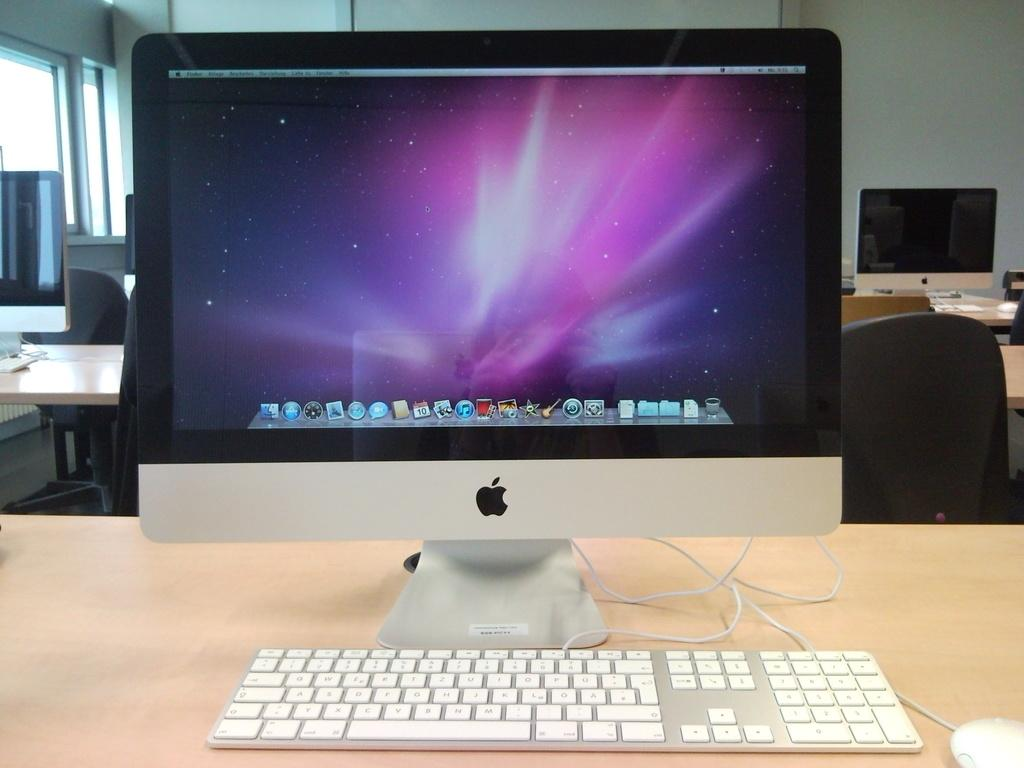What type of furniture is present in the image? There are chairs and tables in the image. What is placed on the tables? Monitors, keyboards, and mice are placed on the tables. What can be seen in the background of the image? There is a wall and a glass window in the background of the image. What is the smell of the chairs in the image? There is no information about the smell of the chairs in the image, as it is a visual medium. 